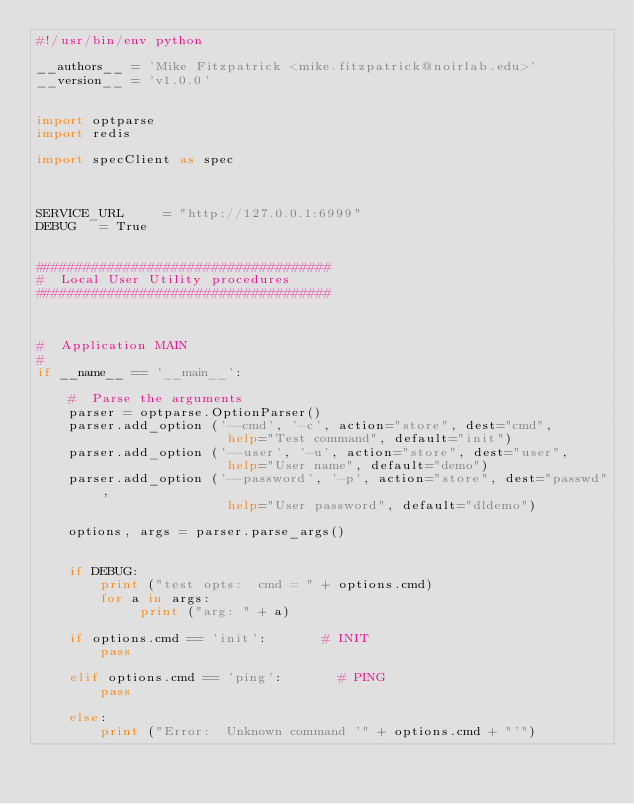<code> <loc_0><loc_0><loc_500><loc_500><_Python_>#!/usr/bin/env python

__authors__ = 'Mike Fitzpatrick <mike.fitzpatrick@noirlab.edu>'
__version__ = 'v1.0.0'


import optparse
import redis

import specClient as spec



SERVICE_URL     = "http://127.0.0.1:6999"
DEBUG		= True


#####################################
#  Local User Utility procedures
#####################################



#  Application MAIN
#
if __name__ == '__main__':

    #  Parse the arguments
    parser = optparse.OptionParser()
    parser.add_option ('--cmd', '-c', action="store", dest="cmd",
                        help="Test command", default="init")
    parser.add_option ('--user', '-u', action="store", dest="user",
                        help="User name", default="demo")
    parser.add_option ('--password', '-p', action="store", dest="passwd",
                        help="User password", default="dldemo")

    options, args = parser.parse_args()


    if DEBUG:
        print ("test opts:  cmd = " + options.cmd)
        for a in args:
             print ("arg: " + a)

    if options.cmd == 'init':				# INIT
        pass

    elif options.cmd == 'ping':				# PING
        pass

    else:
        print ("Error:  Unknown command '" + options.cmd + "'")


</code> 